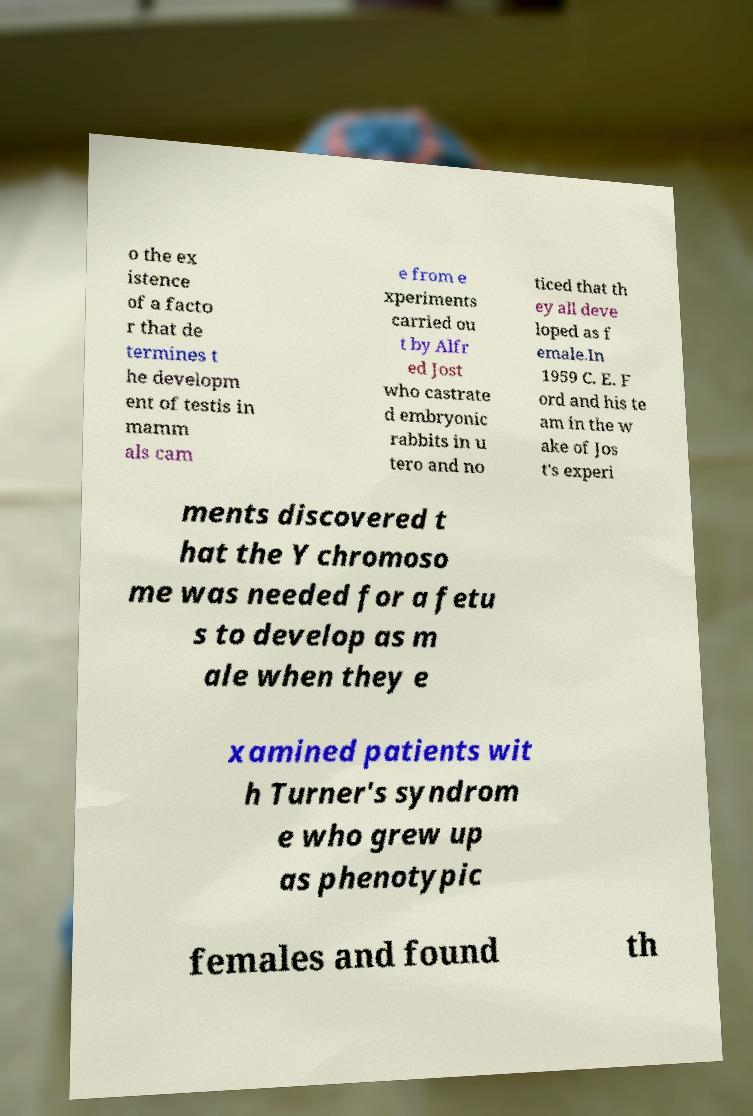Please identify and transcribe the text found in this image. o the ex istence of a facto r that de termines t he developm ent of testis in mamm als cam e from e xperiments carried ou t by Alfr ed Jost who castrate d embryonic rabbits in u tero and no ticed that th ey all deve loped as f emale.In 1959 C. E. F ord and his te am in the w ake of Jos t's experi ments discovered t hat the Y chromoso me was needed for a fetu s to develop as m ale when they e xamined patients wit h Turner's syndrom e who grew up as phenotypic females and found th 